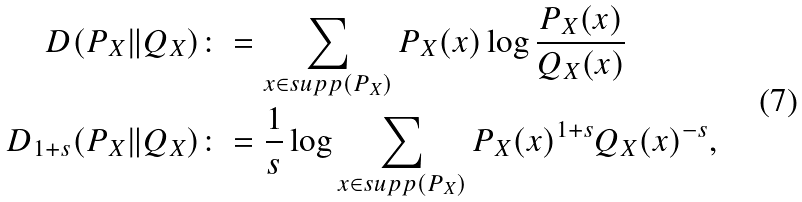<formula> <loc_0><loc_0><loc_500><loc_500>D ( P _ { X } \| Q _ { X } ) & \colon = \sum _ { x \in s u p p ( P _ { X } ) } P _ { X } ( x ) \log \frac { P _ { X } ( x ) } { Q _ { X } ( x ) } \\ D _ { 1 + s } ( P _ { X } \| Q _ { X } ) & \colon = \frac { 1 } { s } \log \sum _ { x \in s u p p ( P _ { X } ) } P _ { X } ( x ) ^ { 1 + s } Q _ { X } ( x ) ^ { - s } ,</formula> 